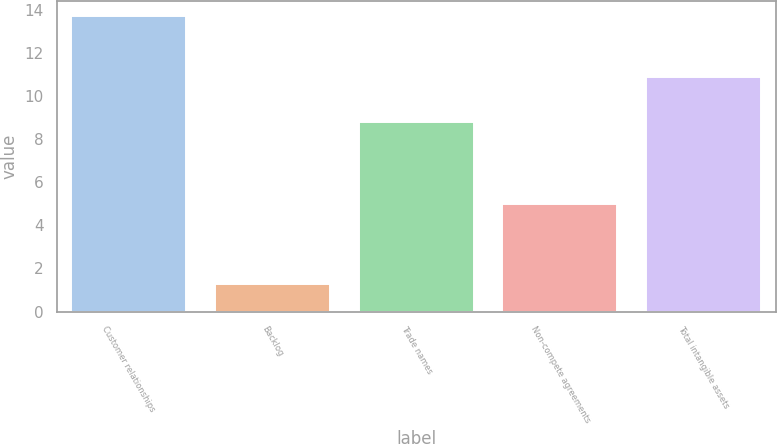<chart> <loc_0><loc_0><loc_500><loc_500><bar_chart><fcel>Customer relationships<fcel>Backlog<fcel>Trade names<fcel>Non-compete agreements<fcel>Total intangible assets<nl><fcel>13.7<fcel>1.3<fcel>8.8<fcel>5<fcel>10.9<nl></chart> 